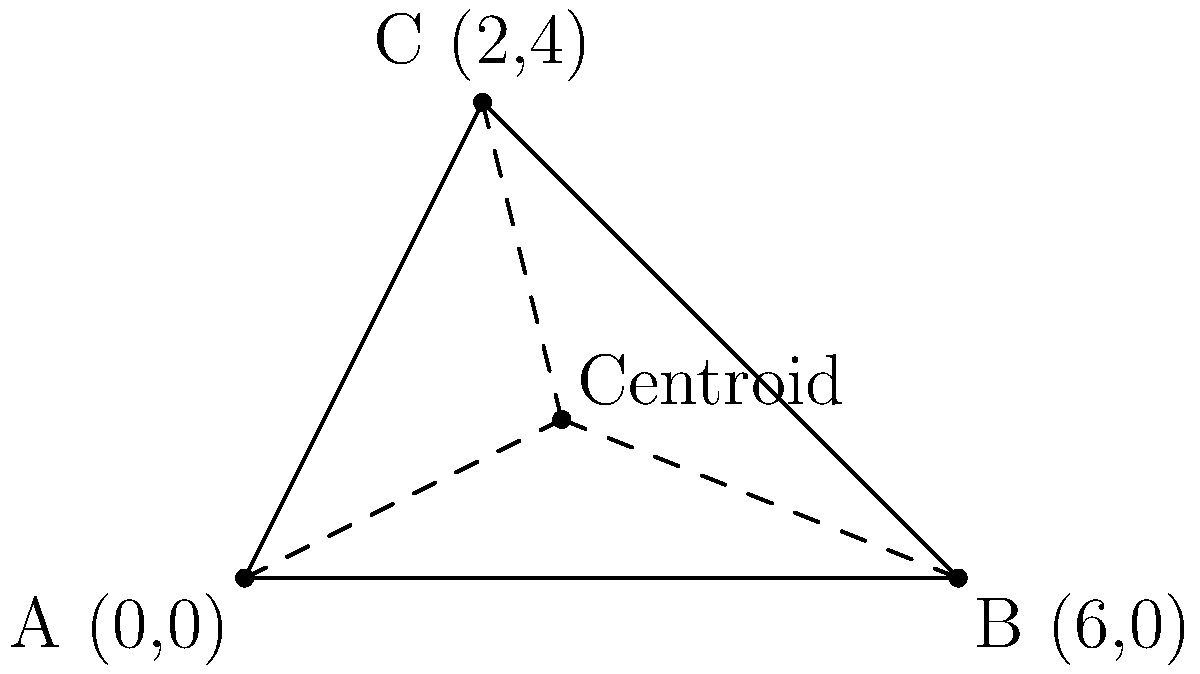As a GIS specialist working on an infrastructure project, you need to find the centroid of a triangular plot of land. The plot is defined by three points: A(0,0), B(6,0), and C(2,4). Calculate the coordinates of the centroid of this triangular plot. To find the centroid of a triangle, we can use the following steps:

1. The centroid formula for a triangle is:
   $$(x_c, y_c) = (\frac{x_1 + x_2 + x_3}{3}, \frac{y_1 + y_2 + y_3}{3})$$
   where $(x_c, y_c)$ are the coordinates of the centroid, and $(x_1, y_1)$, $(x_2, y_2)$, and $(x_3, y_3)$ are the coordinates of the three vertices.

2. We have the following coordinates:
   A(0,0), B(6,0), and C(2,4)

3. Let's calculate the x-coordinate of the centroid:
   $$x_c = \frac{x_1 + x_2 + x_3}{3} = \frac{0 + 6 + 2}{3} = \frac{8}{3} \approx 2.67$$

4. Now, let's calculate the y-coordinate of the centroid:
   $$y_c = \frac{y_1 + y_2 + y_3}{3} = \frac{0 + 0 + 4}{3} = \frac{4}{3} \approx 1.33$$

5. Therefore, the coordinates of the centroid are $(\frac{8}{3}, \frac{4}{3})$ or approximately (2.67, 1.33).
Answer: $(\frac{8}{3}, \frac{4}{3})$ 